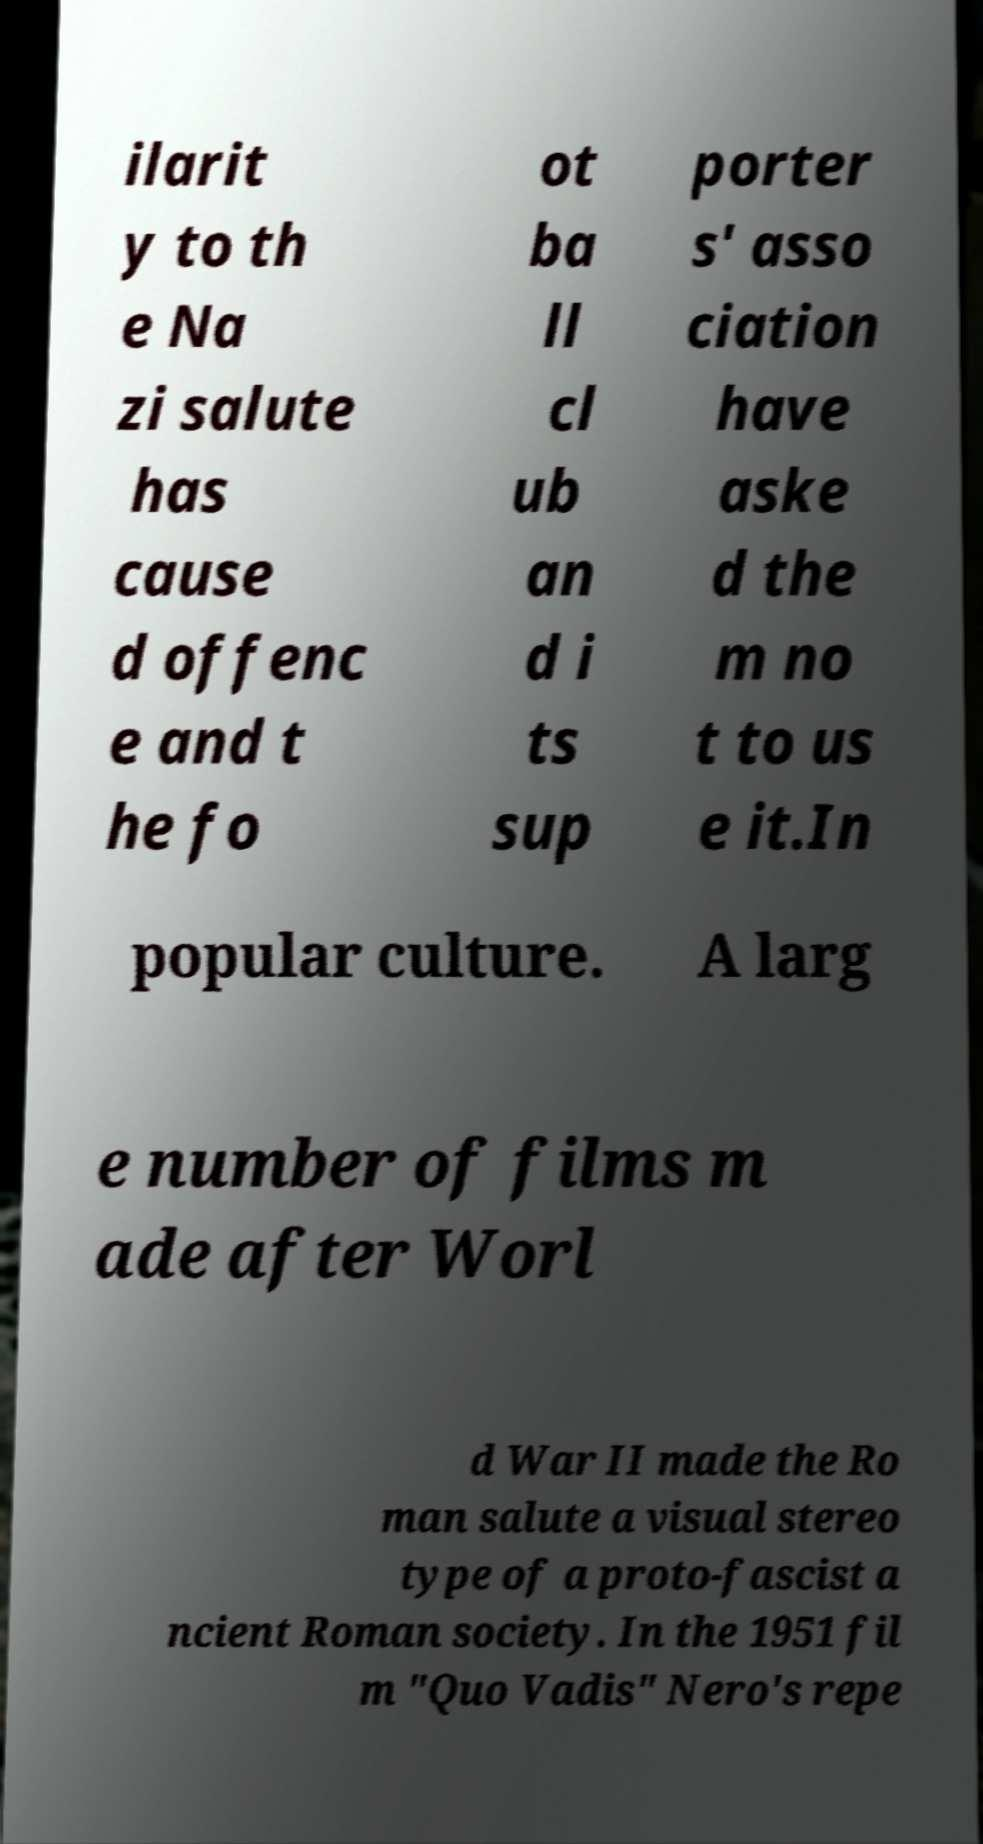There's text embedded in this image that I need extracted. Can you transcribe it verbatim? ilarit y to th e Na zi salute has cause d offenc e and t he fo ot ba ll cl ub an d i ts sup porter s' asso ciation have aske d the m no t to us e it.In popular culture. A larg e number of films m ade after Worl d War II made the Ro man salute a visual stereo type of a proto-fascist a ncient Roman society. In the 1951 fil m "Quo Vadis" Nero's repe 